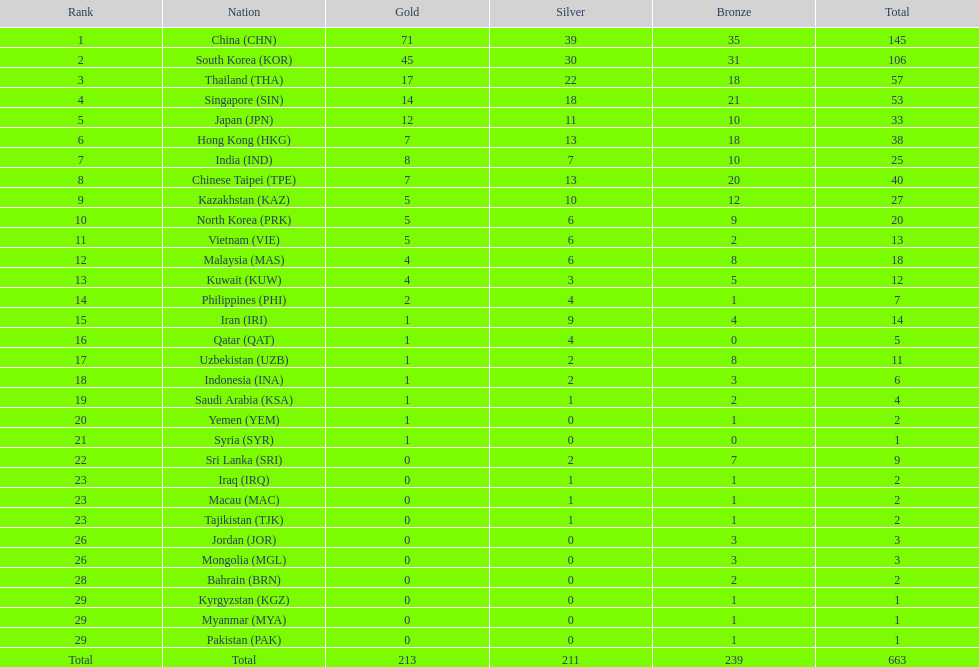Which nation has more gold medals, kuwait or india? India (IND). Parse the table in full. {'header': ['Rank', 'Nation', 'Gold', 'Silver', 'Bronze', 'Total'], 'rows': [['1', 'China\xa0(CHN)', '71', '39', '35', '145'], ['2', 'South Korea\xa0(KOR)', '45', '30', '31', '106'], ['3', 'Thailand\xa0(THA)', '17', '22', '18', '57'], ['4', 'Singapore\xa0(SIN)', '14', '18', '21', '53'], ['5', 'Japan\xa0(JPN)', '12', '11', '10', '33'], ['6', 'Hong Kong\xa0(HKG)', '7', '13', '18', '38'], ['7', 'India\xa0(IND)', '8', '7', '10', '25'], ['8', 'Chinese Taipei\xa0(TPE)', '7', '13', '20', '40'], ['9', 'Kazakhstan\xa0(KAZ)', '5', '10', '12', '27'], ['10', 'North Korea\xa0(PRK)', '5', '6', '9', '20'], ['11', 'Vietnam\xa0(VIE)', '5', '6', '2', '13'], ['12', 'Malaysia\xa0(MAS)', '4', '6', '8', '18'], ['13', 'Kuwait\xa0(KUW)', '4', '3', '5', '12'], ['14', 'Philippines\xa0(PHI)', '2', '4', '1', '7'], ['15', 'Iran\xa0(IRI)', '1', '9', '4', '14'], ['16', 'Qatar\xa0(QAT)', '1', '4', '0', '5'], ['17', 'Uzbekistan\xa0(UZB)', '1', '2', '8', '11'], ['18', 'Indonesia\xa0(INA)', '1', '2', '3', '6'], ['19', 'Saudi Arabia\xa0(KSA)', '1', '1', '2', '4'], ['20', 'Yemen\xa0(YEM)', '1', '0', '1', '2'], ['21', 'Syria\xa0(SYR)', '1', '0', '0', '1'], ['22', 'Sri Lanka\xa0(SRI)', '0', '2', '7', '9'], ['23', 'Iraq\xa0(IRQ)', '0', '1', '1', '2'], ['23', 'Macau\xa0(MAC)', '0', '1', '1', '2'], ['23', 'Tajikistan\xa0(TJK)', '0', '1', '1', '2'], ['26', 'Jordan\xa0(JOR)', '0', '0', '3', '3'], ['26', 'Mongolia\xa0(MGL)', '0', '0', '3', '3'], ['28', 'Bahrain\xa0(BRN)', '0', '0', '2', '2'], ['29', 'Kyrgyzstan\xa0(KGZ)', '0', '0', '1', '1'], ['29', 'Myanmar\xa0(MYA)', '0', '0', '1', '1'], ['29', 'Pakistan\xa0(PAK)', '0', '0', '1', '1'], ['Total', 'Total', '213', '211', '239', '663']]} 